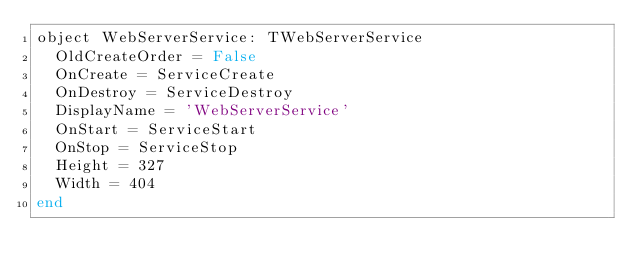Convert code to text. <code><loc_0><loc_0><loc_500><loc_500><_Pascal_>object WebServerService: TWebServerService
  OldCreateOrder = False
  OnCreate = ServiceCreate
  OnDestroy = ServiceDestroy
  DisplayName = 'WebServerService'
  OnStart = ServiceStart
  OnStop = ServiceStop
  Height = 327
  Width = 404
end
</code> 